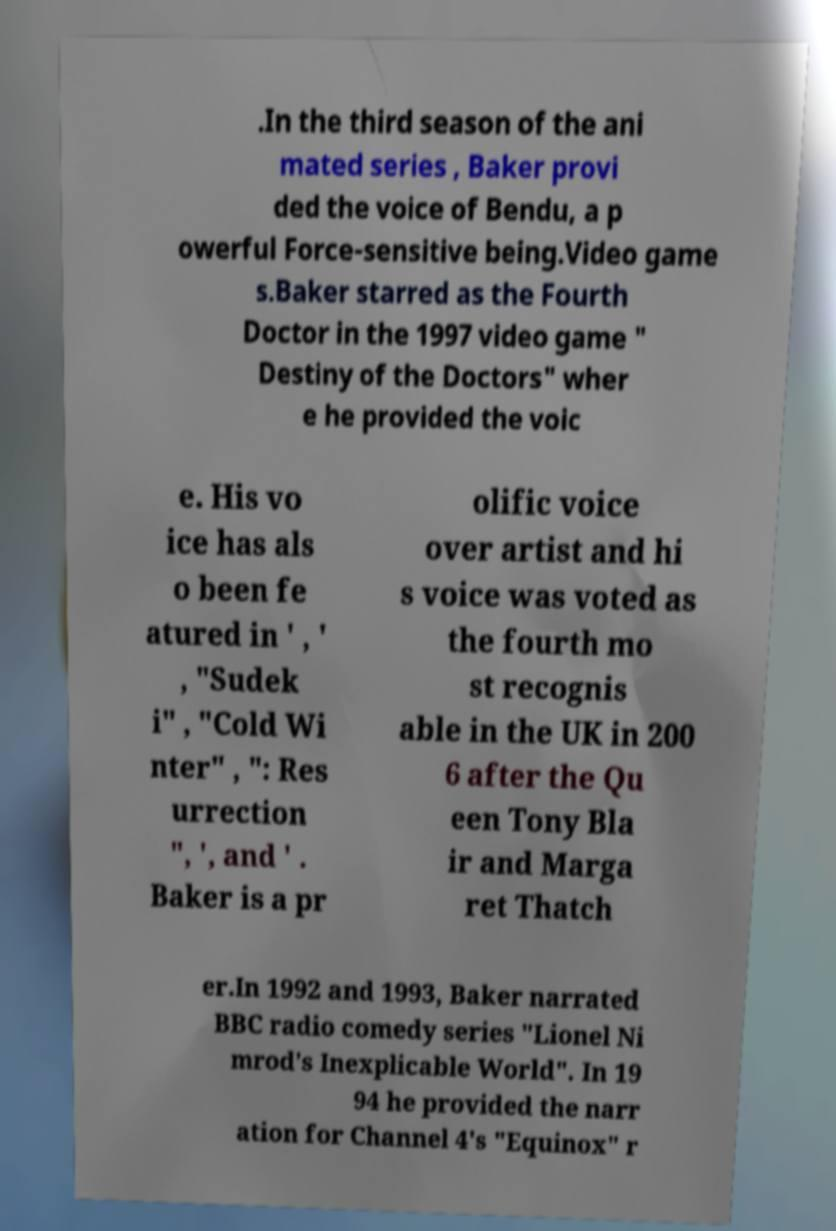Please identify and transcribe the text found in this image. .In the third season of the ani mated series , Baker provi ded the voice of Bendu, a p owerful Force-sensitive being.Video game s.Baker starred as the Fourth Doctor in the 1997 video game " Destiny of the Doctors" wher e he provided the voic e. His vo ice has als o been fe atured in ' , ' , "Sudek i" , "Cold Wi nter" , ": Res urrection ", ', and ' . Baker is a pr olific voice over artist and hi s voice was voted as the fourth mo st recognis able in the UK in 200 6 after the Qu een Tony Bla ir and Marga ret Thatch er.In 1992 and 1993, Baker narrated BBC radio comedy series "Lionel Ni mrod's Inexplicable World". In 19 94 he provided the narr ation for Channel 4's "Equinox" r 